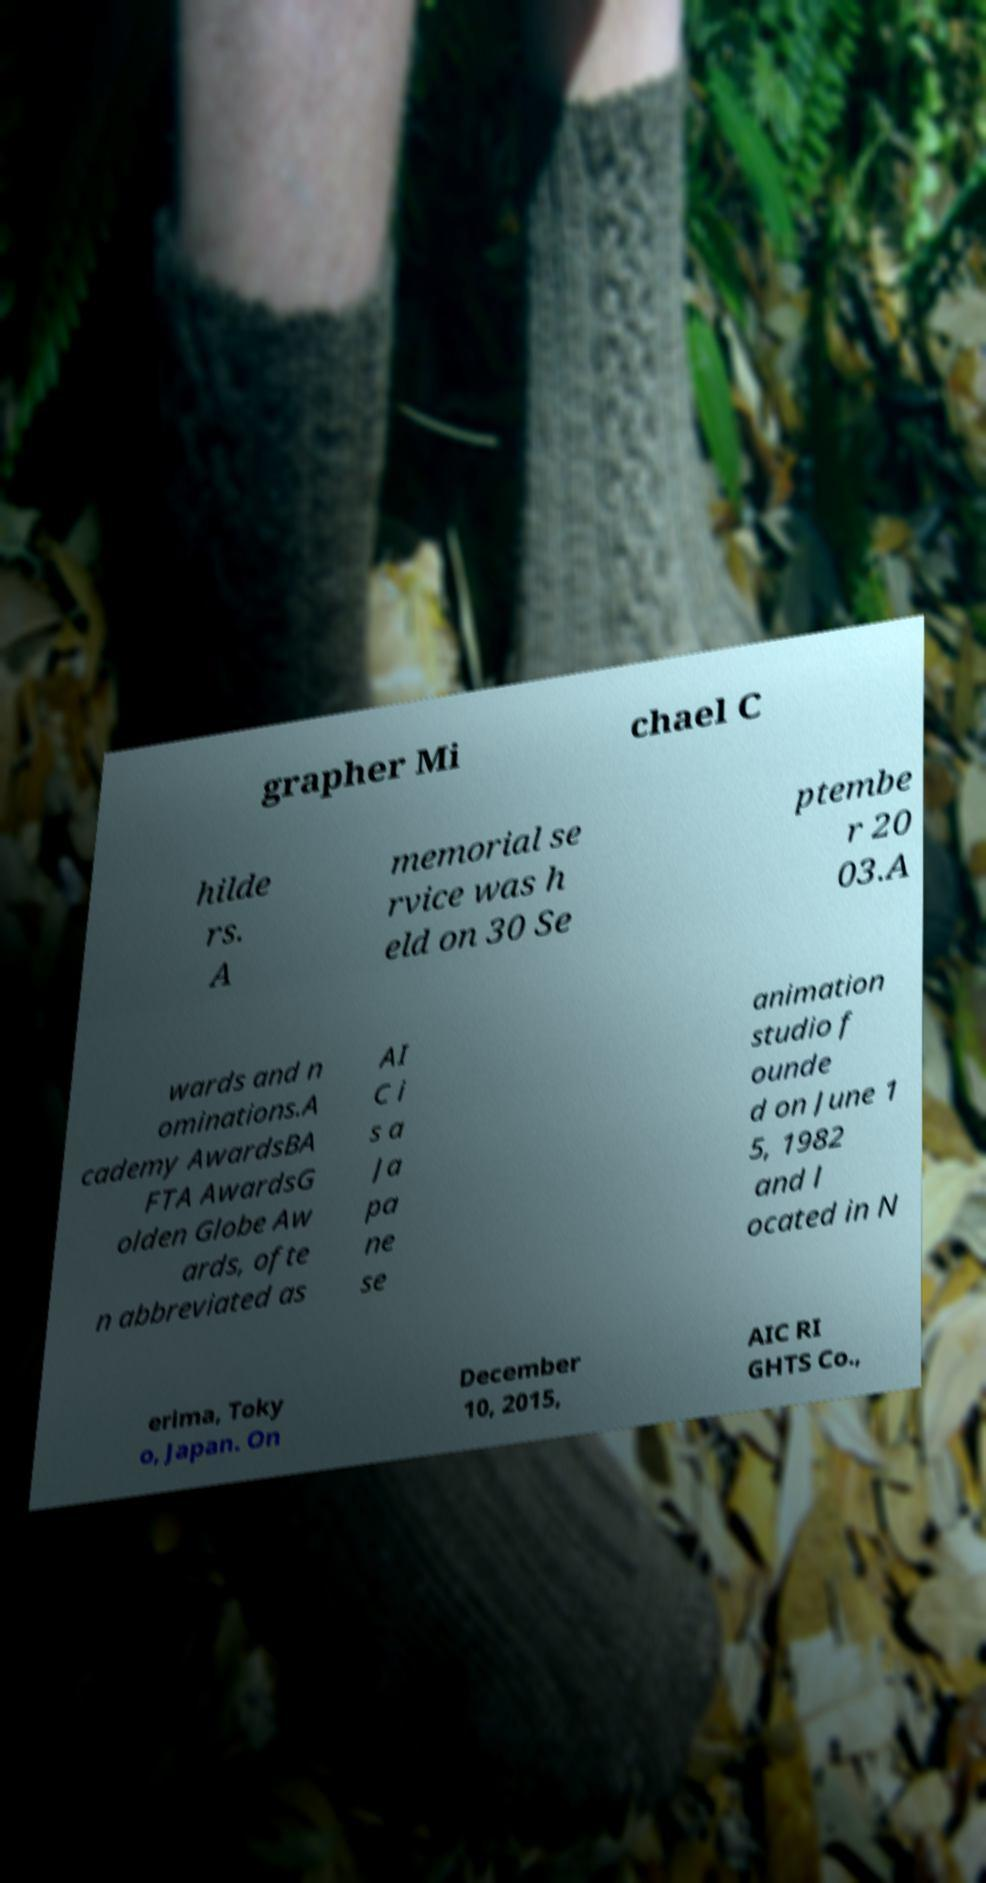Can you accurately transcribe the text from the provided image for me? grapher Mi chael C hilde rs. A memorial se rvice was h eld on 30 Se ptembe r 20 03.A wards and n ominations.A cademy AwardsBA FTA AwardsG olden Globe Aw ards, ofte n abbreviated as AI C i s a Ja pa ne se animation studio f ounde d on June 1 5, 1982 and l ocated in N erima, Toky o, Japan. On December 10, 2015, AIC RI GHTS Co., 